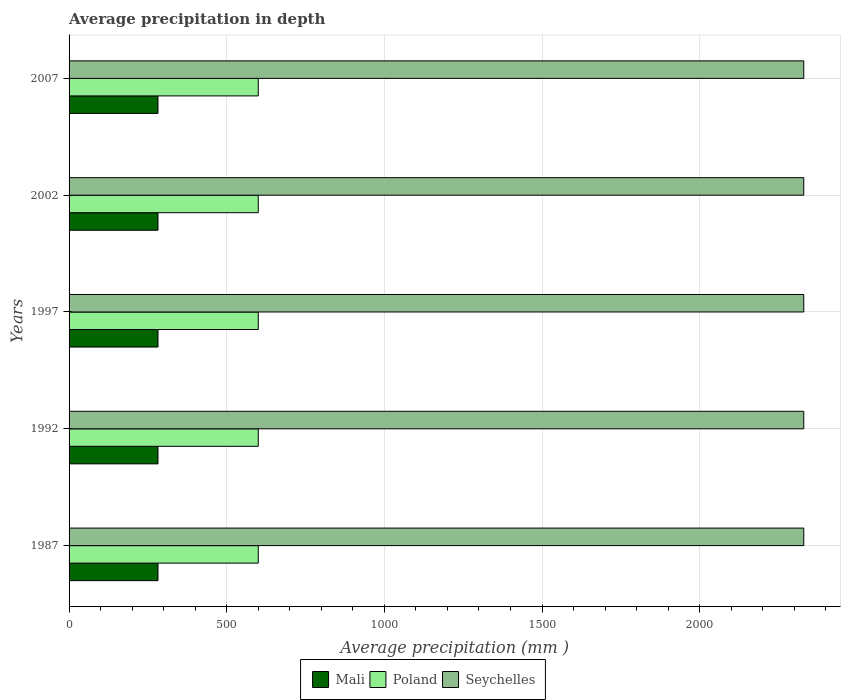How many different coloured bars are there?
Your answer should be compact. 3. How many bars are there on the 1st tick from the bottom?
Give a very brief answer. 3. What is the label of the 5th group of bars from the top?
Your response must be concise. 1987. In how many cases, is the number of bars for a given year not equal to the number of legend labels?
Provide a short and direct response. 0. What is the average precipitation in Poland in 1987?
Provide a succinct answer. 600. Across all years, what is the maximum average precipitation in Poland?
Offer a terse response. 600. Across all years, what is the minimum average precipitation in Seychelles?
Give a very brief answer. 2330. In which year was the average precipitation in Seychelles maximum?
Offer a terse response. 1987. In which year was the average precipitation in Mali minimum?
Provide a succinct answer. 1987. What is the total average precipitation in Mali in the graph?
Offer a very short reply. 1410. What is the difference between the average precipitation in Poland in 1987 and the average precipitation in Seychelles in 2007?
Ensure brevity in your answer.  -1730. What is the average average precipitation in Poland per year?
Keep it short and to the point. 600. In the year 1997, what is the difference between the average precipitation in Mali and average precipitation in Poland?
Keep it short and to the point. -318. What is the ratio of the average precipitation in Mali in 1992 to that in 2002?
Keep it short and to the point. 1. Is the difference between the average precipitation in Mali in 1992 and 2007 greater than the difference between the average precipitation in Poland in 1992 and 2007?
Make the answer very short. No. What is the difference between the highest and the second highest average precipitation in Seychelles?
Offer a very short reply. 0. In how many years, is the average precipitation in Mali greater than the average average precipitation in Mali taken over all years?
Keep it short and to the point. 0. Is the sum of the average precipitation in Poland in 1987 and 2007 greater than the maximum average precipitation in Seychelles across all years?
Your answer should be compact. No. What does the 2nd bar from the top in 2002 represents?
Offer a very short reply. Poland. What does the 1st bar from the bottom in 2002 represents?
Offer a terse response. Mali. Is it the case that in every year, the sum of the average precipitation in Seychelles and average precipitation in Poland is greater than the average precipitation in Mali?
Offer a very short reply. Yes. How many bars are there?
Provide a succinct answer. 15. How many years are there in the graph?
Give a very brief answer. 5. Are the values on the major ticks of X-axis written in scientific E-notation?
Provide a succinct answer. No. Does the graph contain any zero values?
Offer a terse response. No. Does the graph contain grids?
Offer a very short reply. Yes. How many legend labels are there?
Make the answer very short. 3. How are the legend labels stacked?
Offer a very short reply. Horizontal. What is the title of the graph?
Give a very brief answer. Average precipitation in depth. Does "Spain" appear as one of the legend labels in the graph?
Give a very brief answer. No. What is the label or title of the X-axis?
Provide a succinct answer. Average precipitation (mm ). What is the label or title of the Y-axis?
Offer a very short reply. Years. What is the Average precipitation (mm ) in Mali in 1987?
Offer a terse response. 282. What is the Average precipitation (mm ) in Poland in 1987?
Your answer should be very brief. 600. What is the Average precipitation (mm ) in Seychelles in 1987?
Provide a short and direct response. 2330. What is the Average precipitation (mm ) in Mali in 1992?
Your answer should be very brief. 282. What is the Average precipitation (mm ) in Poland in 1992?
Give a very brief answer. 600. What is the Average precipitation (mm ) of Seychelles in 1992?
Give a very brief answer. 2330. What is the Average precipitation (mm ) in Mali in 1997?
Keep it short and to the point. 282. What is the Average precipitation (mm ) of Poland in 1997?
Your answer should be very brief. 600. What is the Average precipitation (mm ) of Seychelles in 1997?
Your answer should be very brief. 2330. What is the Average precipitation (mm ) in Mali in 2002?
Make the answer very short. 282. What is the Average precipitation (mm ) of Poland in 2002?
Give a very brief answer. 600. What is the Average precipitation (mm ) of Seychelles in 2002?
Your answer should be compact. 2330. What is the Average precipitation (mm ) of Mali in 2007?
Provide a succinct answer. 282. What is the Average precipitation (mm ) of Poland in 2007?
Make the answer very short. 600. What is the Average precipitation (mm ) of Seychelles in 2007?
Provide a succinct answer. 2330. Across all years, what is the maximum Average precipitation (mm ) in Mali?
Offer a very short reply. 282. Across all years, what is the maximum Average precipitation (mm ) of Poland?
Give a very brief answer. 600. Across all years, what is the maximum Average precipitation (mm ) in Seychelles?
Make the answer very short. 2330. Across all years, what is the minimum Average precipitation (mm ) of Mali?
Give a very brief answer. 282. Across all years, what is the minimum Average precipitation (mm ) of Poland?
Your response must be concise. 600. Across all years, what is the minimum Average precipitation (mm ) of Seychelles?
Your response must be concise. 2330. What is the total Average precipitation (mm ) of Mali in the graph?
Keep it short and to the point. 1410. What is the total Average precipitation (mm ) in Poland in the graph?
Keep it short and to the point. 3000. What is the total Average precipitation (mm ) of Seychelles in the graph?
Give a very brief answer. 1.16e+04. What is the difference between the Average precipitation (mm ) in Poland in 1987 and that in 1992?
Provide a short and direct response. 0. What is the difference between the Average precipitation (mm ) in Seychelles in 1987 and that in 1997?
Offer a very short reply. 0. What is the difference between the Average precipitation (mm ) in Mali in 1987 and that in 2002?
Give a very brief answer. 0. What is the difference between the Average precipitation (mm ) in Mali in 1987 and that in 2007?
Provide a short and direct response. 0. What is the difference between the Average precipitation (mm ) in Poland in 1987 and that in 2007?
Ensure brevity in your answer.  0. What is the difference between the Average precipitation (mm ) in Seychelles in 1987 and that in 2007?
Offer a terse response. 0. What is the difference between the Average precipitation (mm ) of Poland in 1992 and that in 1997?
Provide a short and direct response. 0. What is the difference between the Average precipitation (mm ) in Mali in 1992 and that in 2002?
Keep it short and to the point. 0. What is the difference between the Average precipitation (mm ) of Poland in 1992 and that in 2002?
Make the answer very short. 0. What is the difference between the Average precipitation (mm ) in Poland in 1992 and that in 2007?
Your response must be concise. 0. What is the difference between the Average precipitation (mm ) of Seychelles in 1992 and that in 2007?
Your response must be concise. 0. What is the difference between the Average precipitation (mm ) in Mali in 1997 and that in 2002?
Your answer should be compact. 0. What is the difference between the Average precipitation (mm ) of Mali in 1997 and that in 2007?
Offer a terse response. 0. What is the difference between the Average precipitation (mm ) of Mali in 2002 and that in 2007?
Your answer should be very brief. 0. What is the difference between the Average precipitation (mm ) in Mali in 1987 and the Average precipitation (mm ) in Poland in 1992?
Provide a succinct answer. -318. What is the difference between the Average precipitation (mm ) in Mali in 1987 and the Average precipitation (mm ) in Seychelles in 1992?
Provide a succinct answer. -2048. What is the difference between the Average precipitation (mm ) in Poland in 1987 and the Average precipitation (mm ) in Seychelles in 1992?
Offer a very short reply. -1730. What is the difference between the Average precipitation (mm ) in Mali in 1987 and the Average precipitation (mm ) in Poland in 1997?
Provide a short and direct response. -318. What is the difference between the Average precipitation (mm ) in Mali in 1987 and the Average precipitation (mm ) in Seychelles in 1997?
Ensure brevity in your answer.  -2048. What is the difference between the Average precipitation (mm ) of Poland in 1987 and the Average precipitation (mm ) of Seychelles in 1997?
Ensure brevity in your answer.  -1730. What is the difference between the Average precipitation (mm ) of Mali in 1987 and the Average precipitation (mm ) of Poland in 2002?
Your response must be concise. -318. What is the difference between the Average precipitation (mm ) of Mali in 1987 and the Average precipitation (mm ) of Seychelles in 2002?
Give a very brief answer. -2048. What is the difference between the Average precipitation (mm ) in Poland in 1987 and the Average precipitation (mm ) in Seychelles in 2002?
Provide a short and direct response. -1730. What is the difference between the Average precipitation (mm ) in Mali in 1987 and the Average precipitation (mm ) in Poland in 2007?
Your answer should be very brief. -318. What is the difference between the Average precipitation (mm ) of Mali in 1987 and the Average precipitation (mm ) of Seychelles in 2007?
Keep it short and to the point. -2048. What is the difference between the Average precipitation (mm ) of Poland in 1987 and the Average precipitation (mm ) of Seychelles in 2007?
Give a very brief answer. -1730. What is the difference between the Average precipitation (mm ) of Mali in 1992 and the Average precipitation (mm ) of Poland in 1997?
Ensure brevity in your answer.  -318. What is the difference between the Average precipitation (mm ) of Mali in 1992 and the Average precipitation (mm ) of Seychelles in 1997?
Keep it short and to the point. -2048. What is the difference between the Average precipitation (mm ) in Poland in 1992 and the Average precipitation (mm ) in Seychelles in 1997?
Keep it short and to the point. -1730. What is the difference between the Average precipitation (mm ) of Mali in 1992 and the Average precipitation (mm ) of Poland in 2002?
Make the answer very short. -318. What is the difference between the Average precipitation (mm ) in Mali in 1992 and the Average precipitation (mm ) in Seychelles in 2002?
Give a very brief answer. -2048. What is the difference between the Average precipitation (mm ) of Poland in 1992 and the Average precipitation (mm ) of Seychelles in 2002?
Offer a terse response. -1730. What is the difference between the Average precipitation (mm ) of Mali in 1992 and the Average precipitation (mm ) of Poland in 2007?
Your answer should be very brief. -318. What is the difference between the Average precipitation (mm ) of Mali in 1992 and the Average precipitation (mm ) of Seychelles in 2007?
Your answer should be compact. -2048. What is the difference between the Average precipitation (mm ) of Poland in 1992 and the Average precipitation (mm ) of Seychelles in 2007?
Provide a succinct answer. -1730. What is the difference between the Average precipitation (mm ) of Mali in 1997 and the Average precipitation (mm ) of Poland in 2002?
Provide a short and direct response. -318. What is the difference between the Average precipitation (mm ) in Mali in 1997 and the Average precipitation (mm ) in Seychelles in 2002?
Your answer should be compact. -2048. What is the difference between the Average precipitation (mm ) in Poland in 1997 and the Average precipitation (mm ) in Seychelles in 2002?
Give a very brief answer. -1730. What is the difference between the Average precipitation (mm ) in Mali in 1997 and the Average precipitation (mm ) in Poland in 2007?
Provide a succinct answer. -318. What is the difference between the Average precipitation (mm ) of Mali in 1997 and the Average precipitation (mm ) of Seychelles in 2007?
Your response must be concise. -2048. What is the difference between the Average precipitation (mm ) of Poland in 1997 and the Average precipitation (mm ) of Seychelles in 2007?
Your answer should be compact. -1730. What is the difference between the Average precipitation (mm ) in Mali in 2002 and the Average precipitation (mm ) in Poland in 2007?
Make the answer very short. -318. What is the difference between the Average precipitation (mm ) of Mali in 2002 and the Average precipitation (mm ) of Seychelles in 2007?
Offer a very short reply. -2048. What is the difference between the Average precipitation (mm ) of Poland in 2002 and the Average precipitation (mm ) of Seychelles in 2007?
Keep it short and to the point. -1730. What is the average Average precipitation (mm ) of Mali per year?
Keep it short and to the point. 282. What is the average Average precipitation (mm ) of Poland per year?
Ensure brevity in your answer.  600. What is the average Average precipitation (mm ) of Seychelles per year?
Offer a terse response. 2330. In the year 1987, what is the difference between the Average precipitation (mm ) in Mali and Average precipitation (mm ) in Poland?
Ensure brevity in your answer.  -318. In the year 1987, what is the difference between the Average precipitation (mm ) of Mali and Average precipitation (mm ) of Seychelles?
Your answer should be very brief. -2048. In the year 1987, what is the difference between the Average precipitation (mm ) in Poland and Average precipitation (mm ) in Seychelles?
Offer a very short reply. -1730. In the year 1992, what is the difference between the Average precipitation (mm ) in Mali and Average precipitation (mm ) in Poland?
Give a very brief answer. -318. In the year 1992, what is the difference between the Average precipitation (mm ) in Mali and Average precipitation (mm ) in Seychelles?
Offer a terse response. -2048. In the year 1992, what is the difference between the Average precipitation (mm ) of Poland and Average precipitation (mm ) of Seychelles?
Provide a short and direct response. -1730. In the year 1997, what is the difference between the Average precipitation (mm ) in Mali and Average precipitation (mm ) in Poland?
Your answer should be very brief. -318. In the year 1997, what is the difference between the Average precipitation (mm ) of Mali and Average precipitation (mm ) of Seychelles?
Provide a short and direct response. -2048. In the year 1997, what is the difference between the Average precipitation (mm ) in Poland and Average precipitation (mm ) in Seychelles?
Offer a terse response. -1730. In the year 2002, what is the difference between the Average precipitation (mm ) in Mali and Average precipitation (mm ) in Poland?
Your response must be concise. -318. In the year 2002, what is the difference between the Average precipitation (mm ) of Mali and Average precipitation (mm ) of Seychelles?
Keep it short and to the point. -2048. In the year 2002, what is the difference between the Average precipitation (mm ) in Poland and Average precipitation (mm ) in Seychelles?
Offer a very short reply. -1730. In the year 2007, what is the difference between the Average precipitation (mm ) in Mali and Average precipitation (mm ) in Poland?
Keep it short and to the point. -318. In the year 2007, what is the difference between the Average precipitation (mm ) of Mali and Average precipitation (mm ) of Seychelles?
Ensure brevity in your answer.  -2048. In the year 2007, what is the difference between the Average precipitation (mm ) of Poland and Average precipitation (mm ) of Seychelles?
Keep it short and to the point. -1730. What is the ratio of the Average precipitation (mm ) of Poland in 1987 to that in 1992?
Ensure brevity in your answer.  1. What is the ratio of the Average precipitation (mm ) of Poland in 1987 to that in 1997?
Provide a short and direct response. 1. What is the ratio of the Average precipitation (mm ) of Seychelles in 1987 to that in 2002?
Your answer should be very brief. 1. What is the ratio of the Average precipitation (mm ) of Seychelles in 1987 to that in 2007?
Your answer should be compact. 1. What is the ratio of the Average precipitation (mm ) of Seychelles in 1992 to that in 1997?
Keep it short and to the point. 1. What is the ratio of the Average precipitation (mm ) in Mali in 1992 to that in 2002?
Ensure brevity in your answer.  1. What is the ratio of the Average precipitation (mm ) of Seychelles in 1992 to that in 2002?
Offer a very short reply. 1. What is the ratio of the Average precipitation (mm ) in Seychelles in 1992 to that in 2007?
Keep it short and to the point. 1. What is the ratio of the Average precipitation (mm ) in Poland in 1997 to that in 2007?
Give a very brief answer. 1. What is the ratio of the Average precipitation (mm ) of Mali in 2002 to that in 2007?
Offer a terse response. 1. What is the ratio of the Average precipitation (mm ) of Poland in 2002 to that in 2007?
Keep it short and to the point. 1. What is the ratio of the Average precipitation (mm ) of Seychelles in 2002 to that in 2007?
Offer a very short reply. 1. What is the difference between the highest and the second highest Average precipitation (mm ) in Mali?
Offer a terse response. 0. What is the difference between the highest and the second highest Average precipitation (mm ) of Poland?
Ensure brevity in your answer.  0. What is the difference between the highest and the lowest Average precipitation (mm ) of Mali?
Offer a terse response. 0. What is the difference between the highest and the lowest Average precipitation (mm ) of Poland?
Offer a very short reply. 0. What is the difference between the highest and the lowest Average precipitation (mm ) in Seychelles?
Keep it short and to the point. 0. 